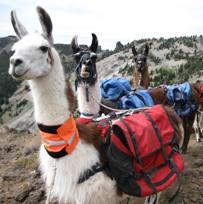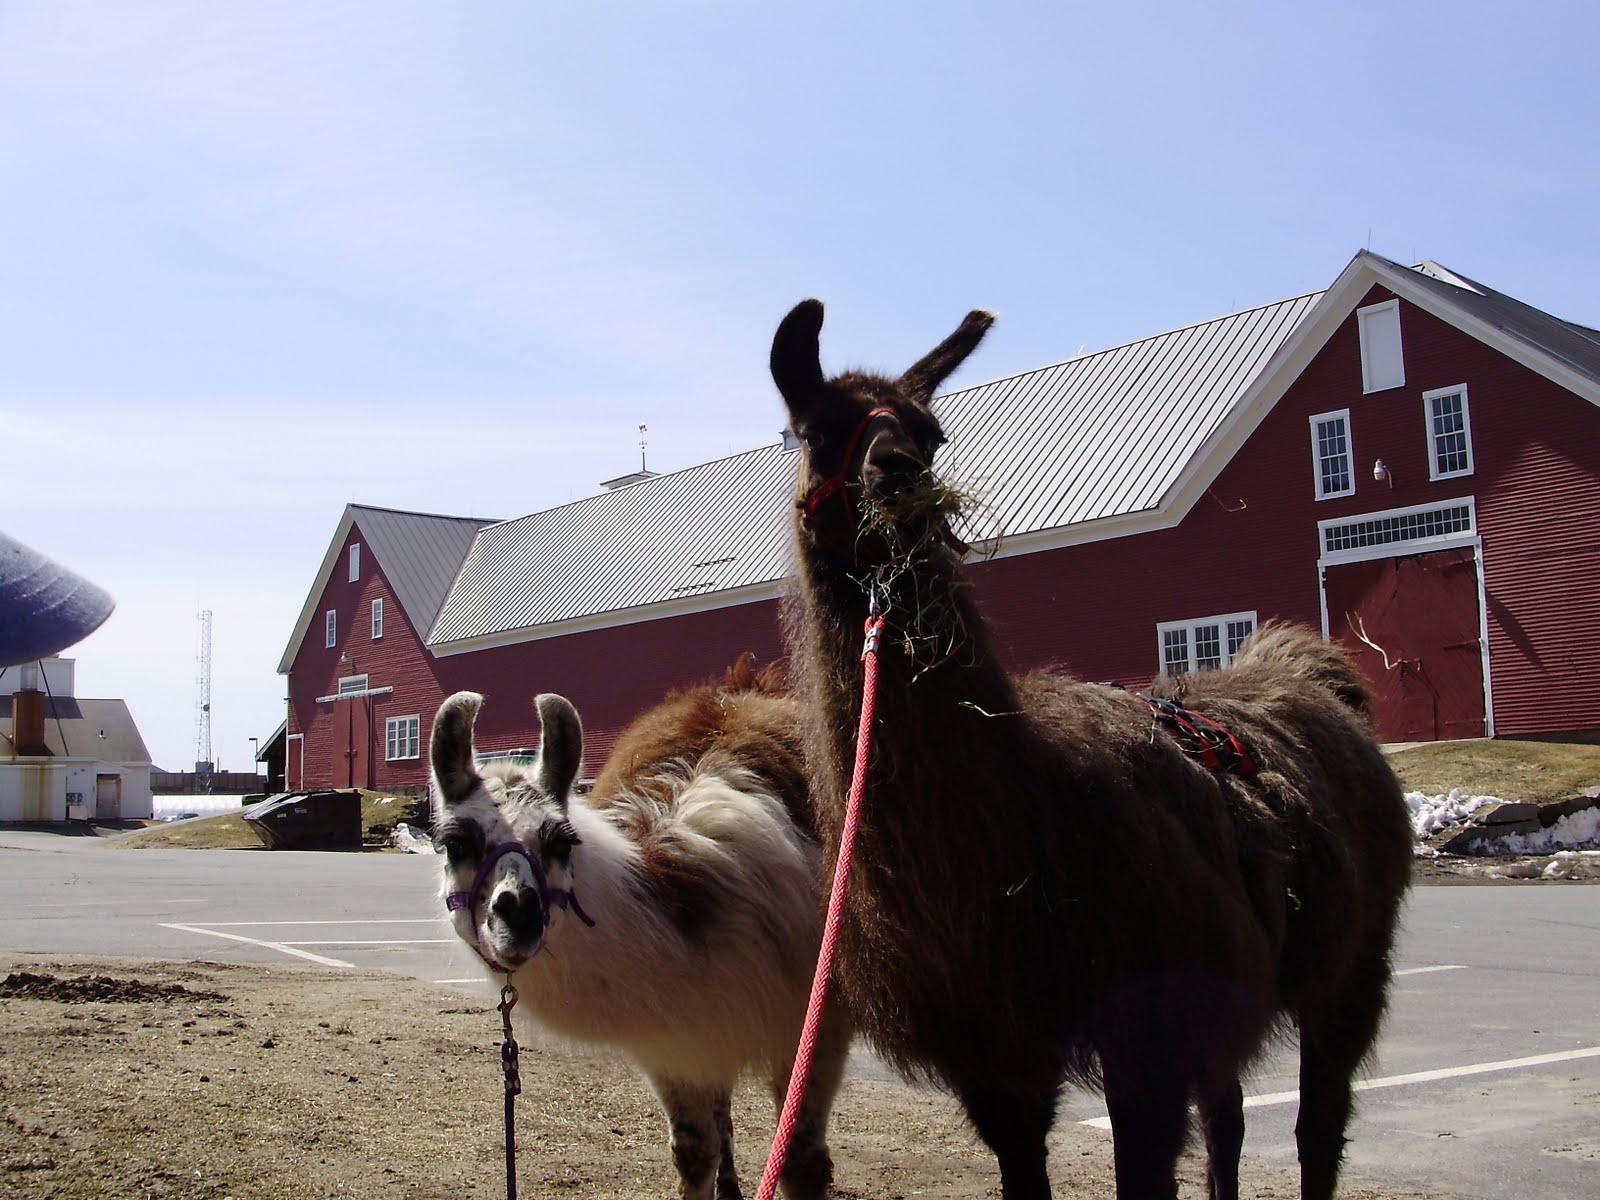The first image is the image on the left, the second image is the image on the right. For the images displayed, is the sentence "A camera-facing man and woman are standing between two pack-wearing llamas and in front of at least one peak." factually correct? Answer yes or no. No. The first image is the image on the left, the second image is the image on the right. For the images shown, is this caption "Both images contain people and llamas." true? Answer yes or no. No. 